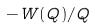Convert formula to latex. <formula><loc_0><loc_0><loc_500><loc_500>- W ( Q ) / Q</formula> 